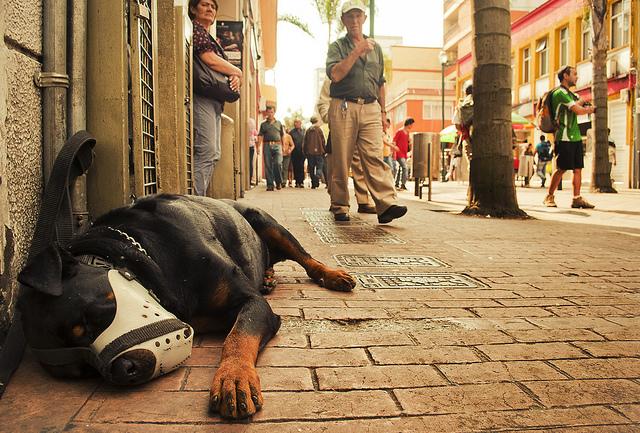Why is this dog wearing mouth guard?
Give a very brief answer. So it won't bite. What is over the dog's mouth?
Short answer required. Muzzle. Is the dog tired?
Be succinct. Yes. 